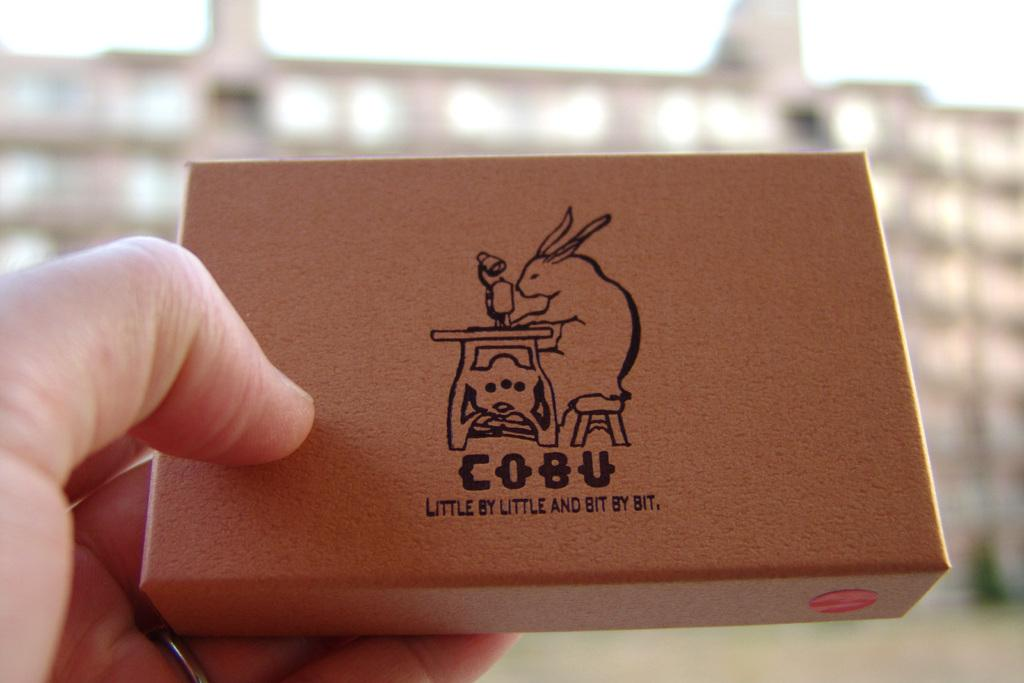<image>
Relay a brief, clear account of the picture shown. a box with a sewing rabbit design for Cobu 